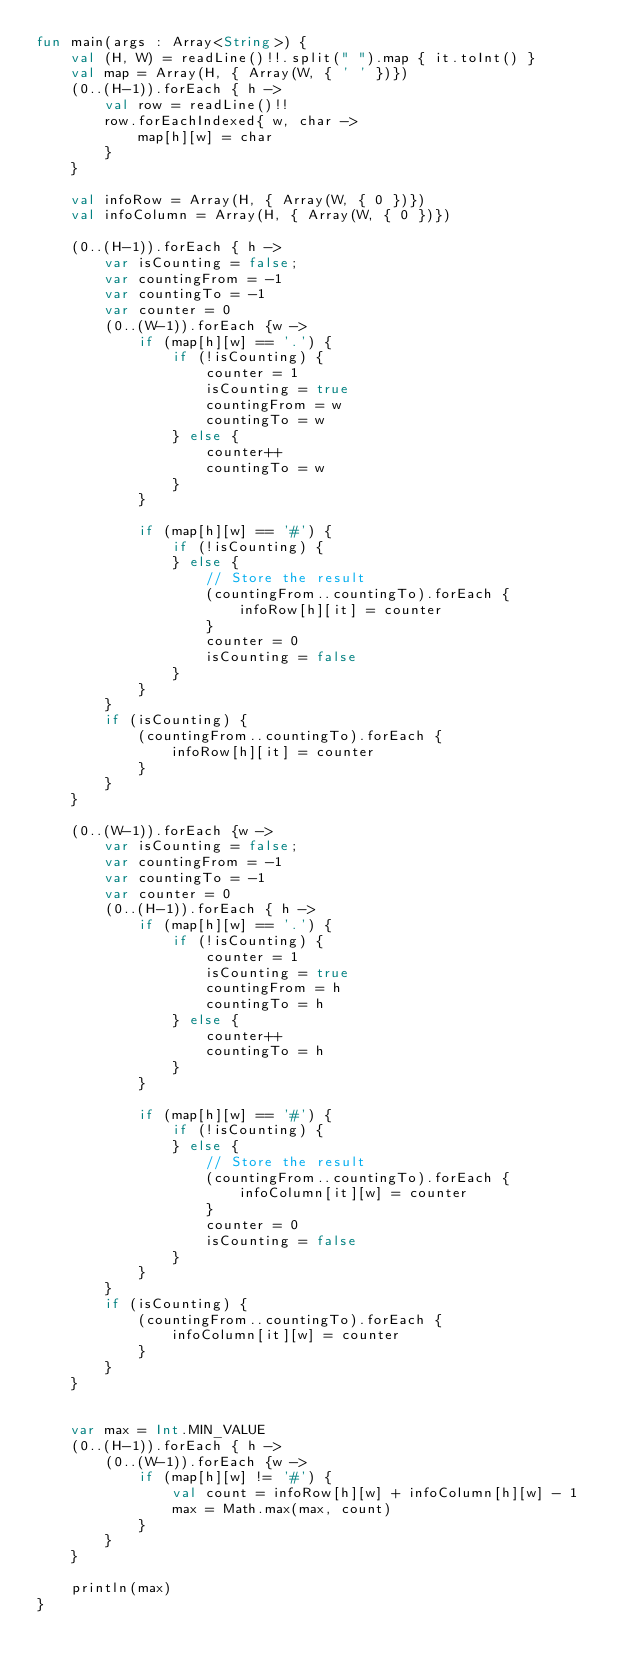Convert code to text. <code><loc_0><loc_0><loc_500><loc_500><_Kotlin_>fun main(args : Array<String>) {
    val (H, W) = readLine()!!.split(" ").map { it.toInt() }
    val map = Array(H, { Array(W, { ' ' })})
    (0..(H-1)).forEach { h ->
        val row = readLine()!!
        row.forEachIndexed{ w, char ->
            map[h][w] = char
        }
    }
 
    val infoRow = Array(H, { Array(W, { 0 })})
    val infoColumn = Array(H, { Array(W, { 0 })})
 
    (0..(H-1)).forEach { h ->
        var isCounting = false;
        var countingFrom = -1
        var countingTo = -1
        var counter = 0
        (0..(W-1)).forEach {w ->
            if (map[h][w] == '.') {
                if (!isCounting) {
                    counter = 1
                    isCounting = true
                    countingFrom = w
                    countingTo = w
                } else {
                    counter++
                    countingTo = w
                }
            }
 
            if (map[h][w] == '#') {
                if (!isCounting) {
                } else {
                    // Store the result
                    (countingFrom..countingTo).forEach {
                        infoRow[h][it] = counter
                    }
                    counter = 0
                    isCounting = false
                }
            }
        }
        if (isCounting) {
            (countingFrom..countingTo).forEach {
                infoRow[h][it] = counter
            }
        }
    }
 
    (0..(W-1)).forEach {w ->
        var isCounting = false;
        var countingFrom = -1
        var countingTo = -1
        var counter = 0
        (0..(H-1)).forEach { h ->
            if (map[h][w] == '.') {
                if (!isCounting) {
                    counter = 1
                    isCounting = true
                    countingFrom = h
                    countingTo = h
                } else {
                    counter++
                    countingTo = h
                }
            }
 
            if (map[h][w] == '#') {
                if (!isCounting) {
                } else {
                    // Store the result
                    (countingFrom..countingTo).forEach {
                        infoColumn[it][w] = counter
                    }
                    counter = 0
                    isCounting = false
                }
            }
        }
        if (isCounting) {
            (countingFrom..countingTo).forEach {
                infoColumn[it][w] = counter
            }
        }
    }
 
 
    var max = Int.MIN_VALUE
    (0..(H-1)).forEach { h ->
        (0..(W-1)).forEach {w ->
            if (map[h][w] != '#') {
                val count = infoRow[h][w] + infoColumn[h][w] - 1
                max = Math.max(max, count)
            }
        }
    }
 
    println(max)
}</code> 